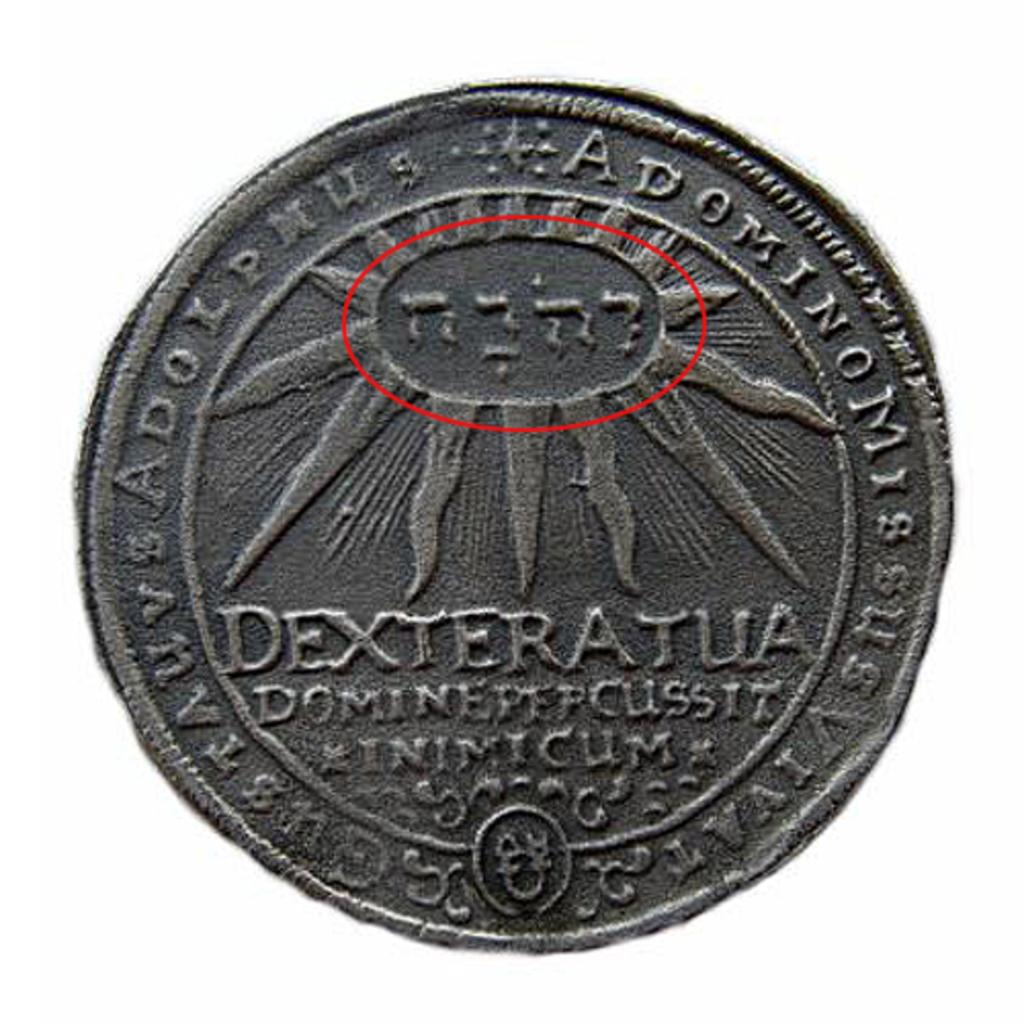Provide a one-sentence caption for the provided image. a coin that says 'dexteratua' on it along with other writings. 